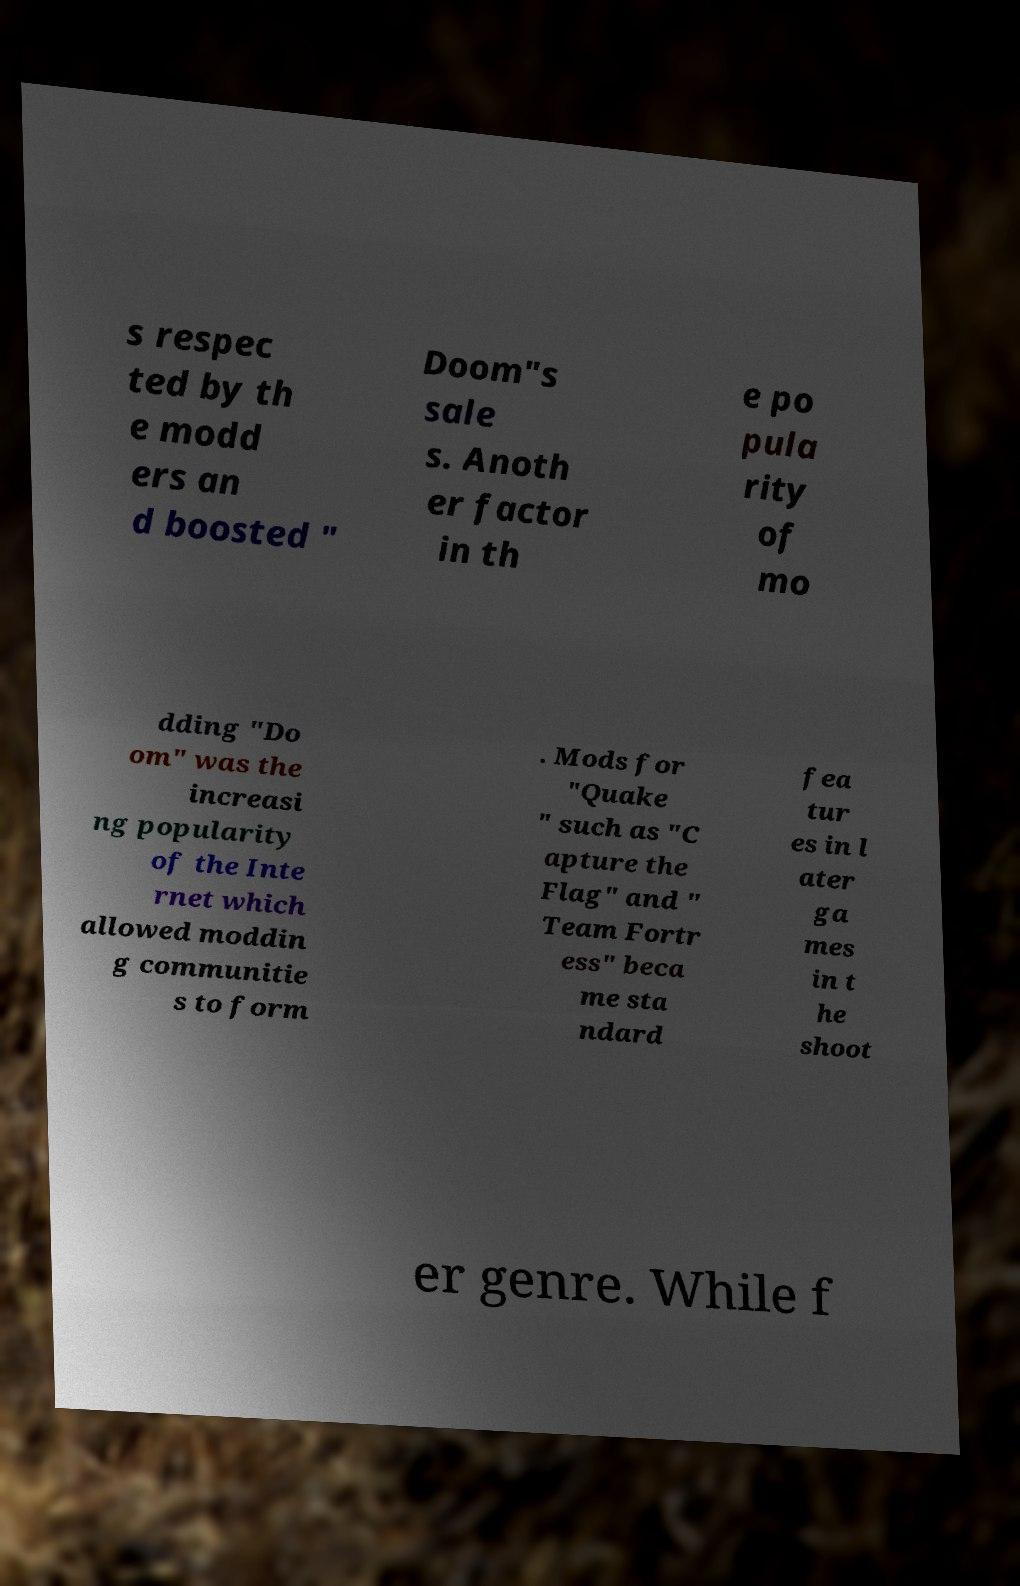What messages or text are displayed in this image? I need them in a readable, typed format. s respec ted by th e modd ers an d boosted " Doom"s sale s. Anoth er factor in th e po pula rity of mo dding "Do om" was the increasi ng popularity of the Inte rnet which allowed moddin g communitie s to form . Mods for "Quake " such as "C apture the Flag" and " Team Fortr ess" beca me sta ndard fea tur es in l ater ga mes in t he shoot er genre. While f 